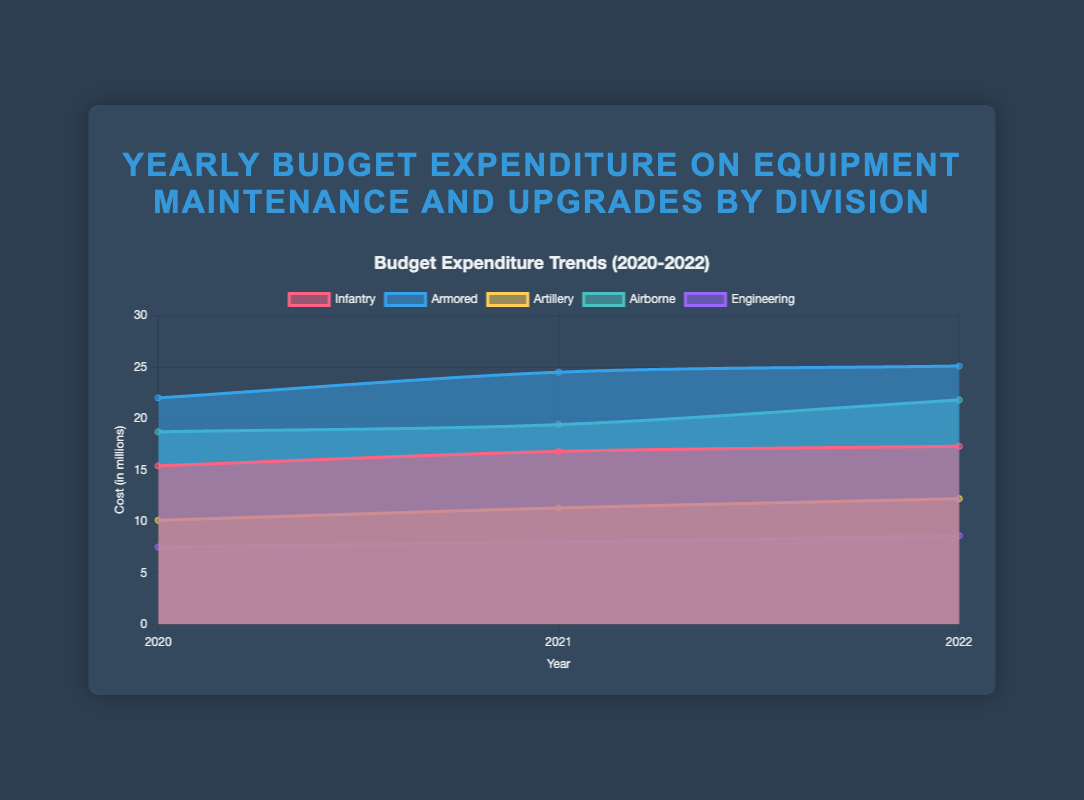What is the title of the chart? The title is prominently displayed at the top above the chart and reads: "Yearly Budget Expenditure on Equipment Maintenance and Upgrades by Division"
Answer: Yearly Budget Expenditure on Equipment Maintenance and Upgrades by Division Which division had the highest expenditure in 2022? The chart shows the values for each division in 2022. The Armored division has the highest expenditure with 25.1 million.
Answer: Armored What is the overall trend in expenditure for the Infantry division from 2020 to 2022? Looking at the Infantry division's line, the trend shows an increase from 15.4 million in 2020 to 17.3 million in 2022.
Answer: Increasing How many divisions are represented in the chart? The legend on the chart breaks down the data by division and lists Infantry, Armored, Artillery, Airborne, and Engineering, making a total of five divisions.
Answer: 5 What is the difference in expenditure between the Airborne and Engineering divisions in 2022? The values for 2022 are Airborne: 21.8 million and Engineering: 8.6 million. The difference is 21.8 - 8.6.
Answer: 13.2 Which division showed the least increase in expenditure from 2021 to 2022? The increase for each division can be calculated: Infantry (0.5 million), Armored (0.6 million), Artillery (0.9 million), Airborne (2.4 million), Engineering (0.6 million). Infantry showed the least increase.
Answer: Infantry What is the total budget expenditure for the Armored and Artillery divisions combined in 2021? Add the 2021 expenditures of Armored (24.5) and Artillery (11.3) divisions.
Answer: 35.8 How does the expenditure of the Engineering division in 2021 compare to that in 2020? The Engineering division's expenditure in 2021 is 8.0 million, compared to 7.5 million in 2020, showing an increase.
Answer: Increased by 0.5 million What is the average yearly expenditure of the Airborne division from 2020 to 2022? The yearly expenditures for Airborne from 2020 to 2022 are 18.7, 19.4, and 21.8 million. The average is (18.7 + 19.4 + 21.8) / 3.
Answer: 19.97 Which division had the second-highest expenditure in 2021? The chart shows expenditures in 2021: Infantry (16.8), Armored (24.5), Artillery (11.3), Airborne (19.4), Engineering (8.0). Airborne, with 19.4 million, ranks second.
Answer: Airborne 